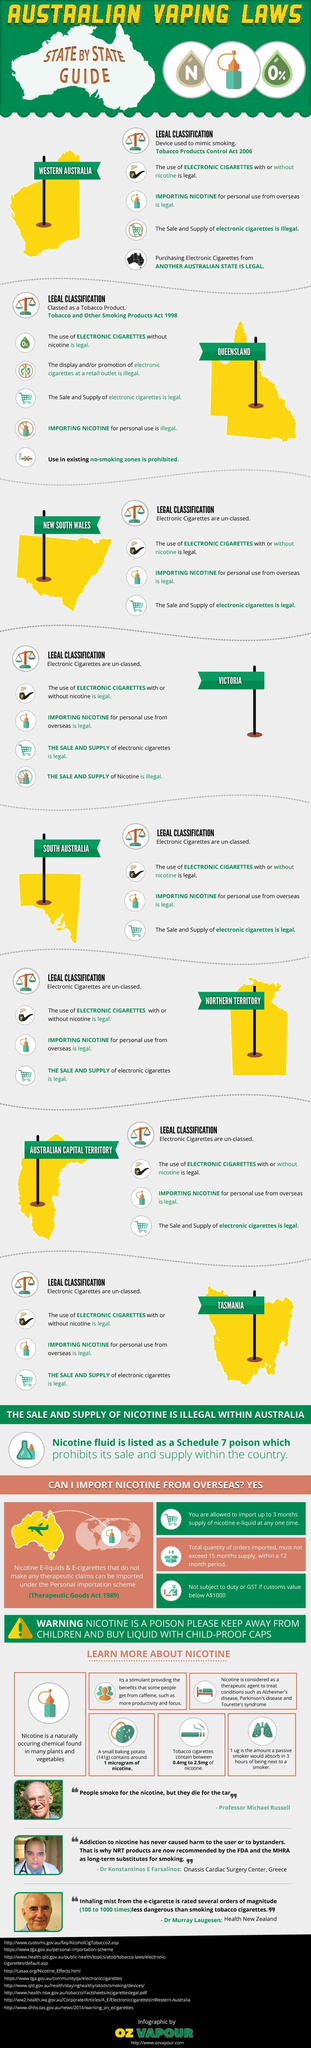Specify some key components in this picture. In Queensland, e-cigarettes are classified as a tobacco product. Nicotine e-liquids can be imported in accordance with the Therapeutic Goods Act 1989. It is illegal to import nicotine for personal use in the state of Queensland. In Western Australia, e-cigarettes are classified as a device used to mimic smoking. An e-cigarette is classified as a device used to mimic smoking in Western Australia. 